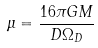Convert formula to latex. <formula><loc_0><loc_0><loc_500><loc_500>\mu = \frac { 1 6 \pi G M } { D \Omega _ { D } }</formula> 